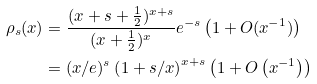Convert formula to latex. <formula><loc_0><loc_0><loc_500><loc_500>\rho _ { s } ( x ) & = \frac { ( x + s + \frac { 1 } { 2 } ) ^ { x + s } } { ( x + \frac { 1 } { 2 } ) ^ { x } } e ^ { - s } \left ( 1 + O ( x ^ { - 1 } ) \right ) \\ & = ( x / e ) ^ { s } \left ( 1 + s / x \right ) ^ { x + s } \left ( 1 + O \left ( x ^ { - 1 } \right ) \right )</formula> 